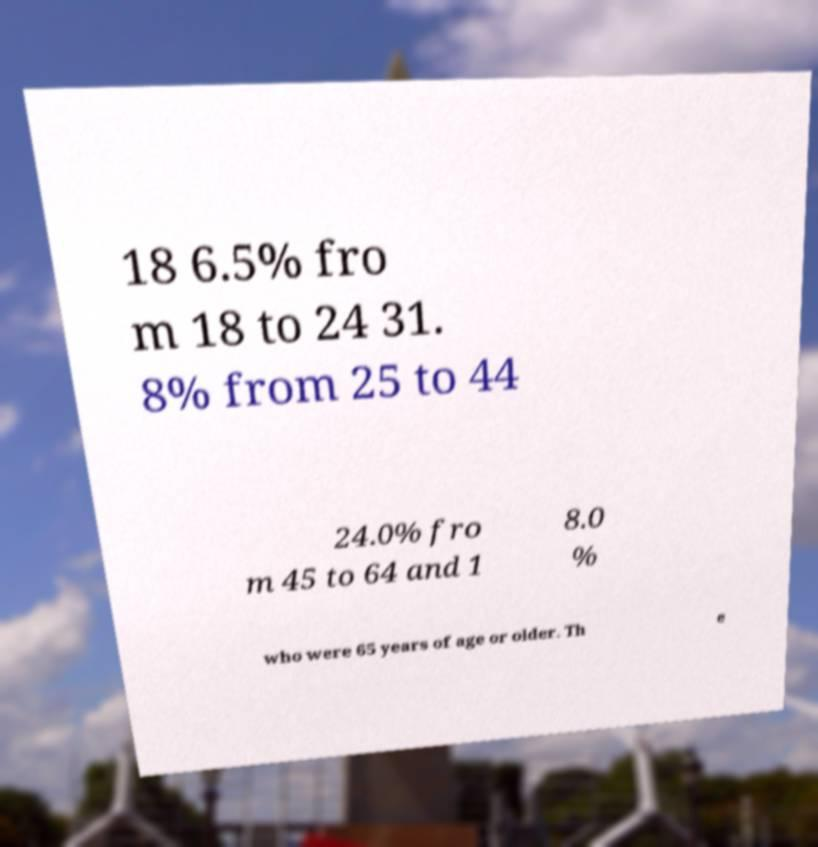For documentation purposes, I need the text within this image transcribed. Could you provide that? 18 6.5% fro m 18 to 24 31. 8% from 25 to 44 24.0% fro m 45 to 64 and 1 8.0 % who were 65 years of age or older. Th e 